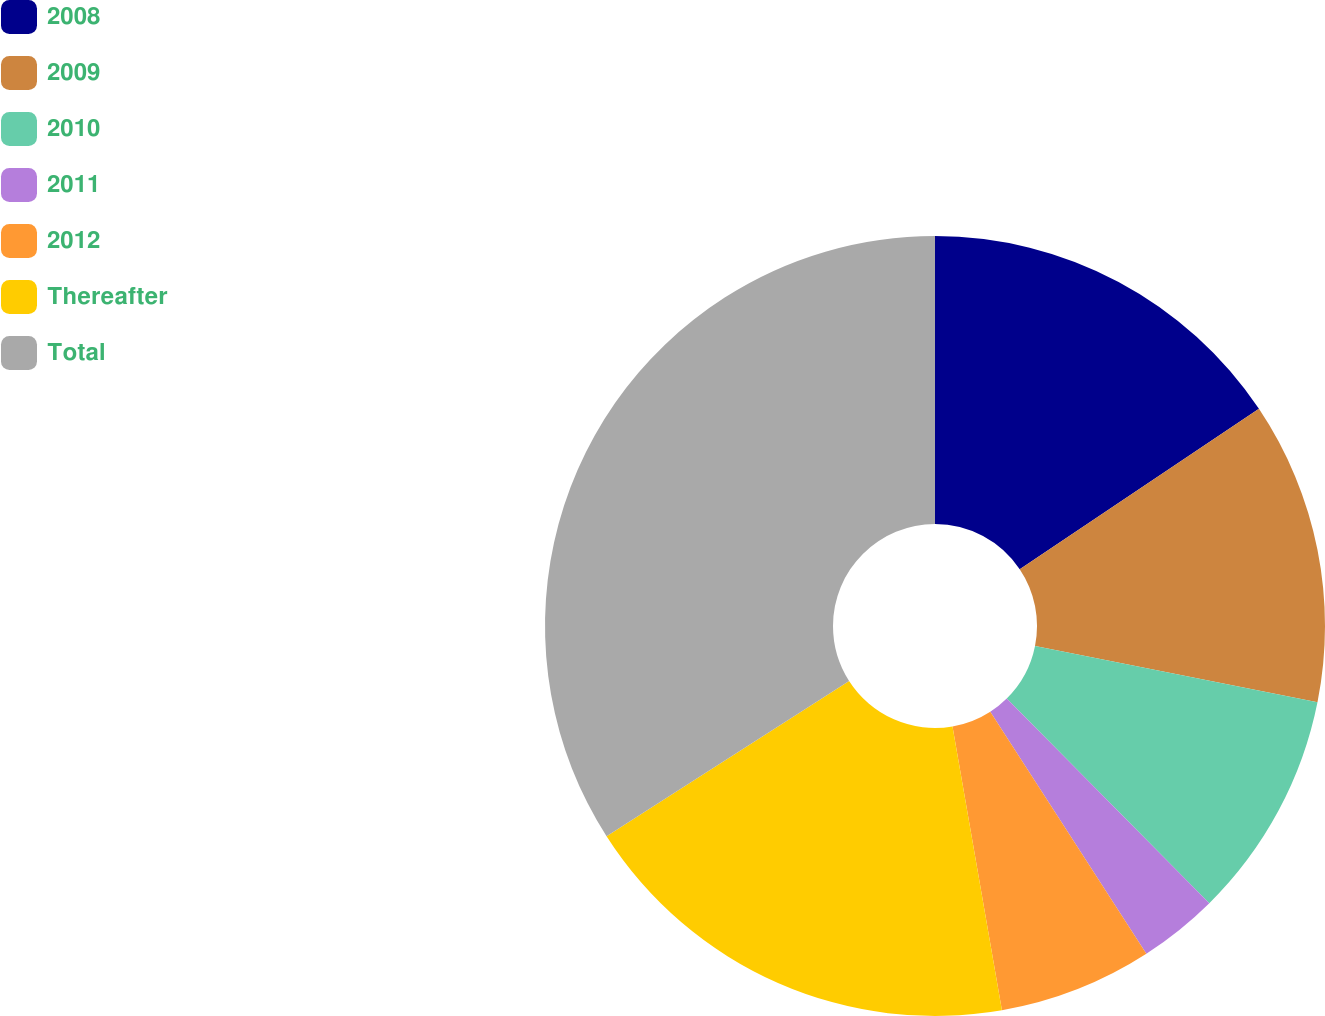<chart> <loc_0><loc_0><loc_500><loc_500><pie_chart><fcel>2008<fcel>2009<fcel>2010<fcel>2011<fcel>2012<fcel>Thereafter<fcel>Total<nl><fcel>15.6%<fcel>12.53%<fcel>9.45%<fcel>3.3%<fcel>6.37%<fcel>18.68%<fcel>34.06%<nl></chart> 